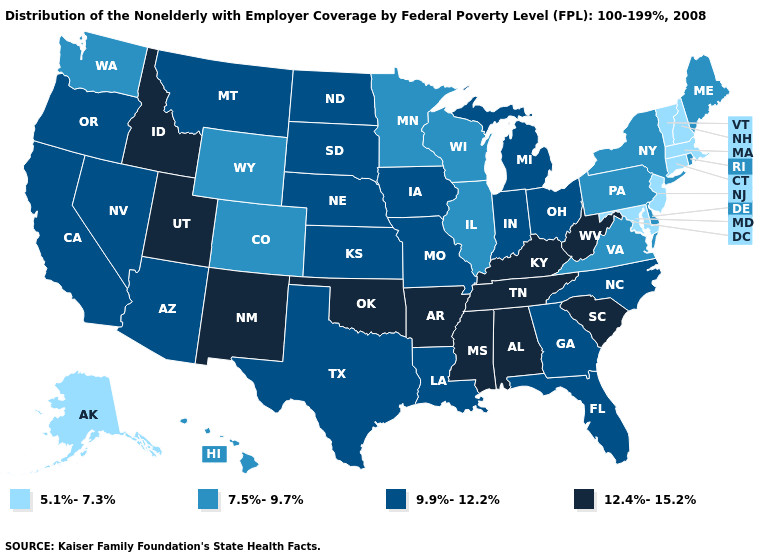Does Wyoming have the lowest value in the USA?
Keep it brief. No. Which states have the lowest value in the USA?
Write a very short answer. Alaska, Connecticut, Maryland, Massachusetts, New Hampshire, New Jersey, Vermont. What is the value of Maryland?
Short answer required. 5.1%-7.3%. Does Wyoming have the same value as Massachusetts?
Concise answer only. No. Is the legend a continuous bar?
Keep it brief. No. What is the value of Kentucky?
Keep it brief. 12.4%-15.2%. What is the value of Georgia?
Concise answer only. 9.9%-12.2%. Among the states that border Louisiana , does Texas have the highest value?
Concise answer only. No. Which states have the lowest value in the South?
Write a very short answer. Maryland. What is the value of Delaware?
Keep it brief. 7.5%-9.7%. Is the legend a continuous bar?
Quick response, please. No. Is the legend a continuous bar?
Be succinct. No. What is the value of Wisconsin?
Quick response, please. 7.5%-9.7%. Name the states that have a value in the range 12.4%-15.2%?
Answer briefly. Alabama, Arkansas, Idaho, Kentucky, Mississippi, New Mexico, Oklahoma, South Carolina, Tennessee, Utah, West Virginia. 